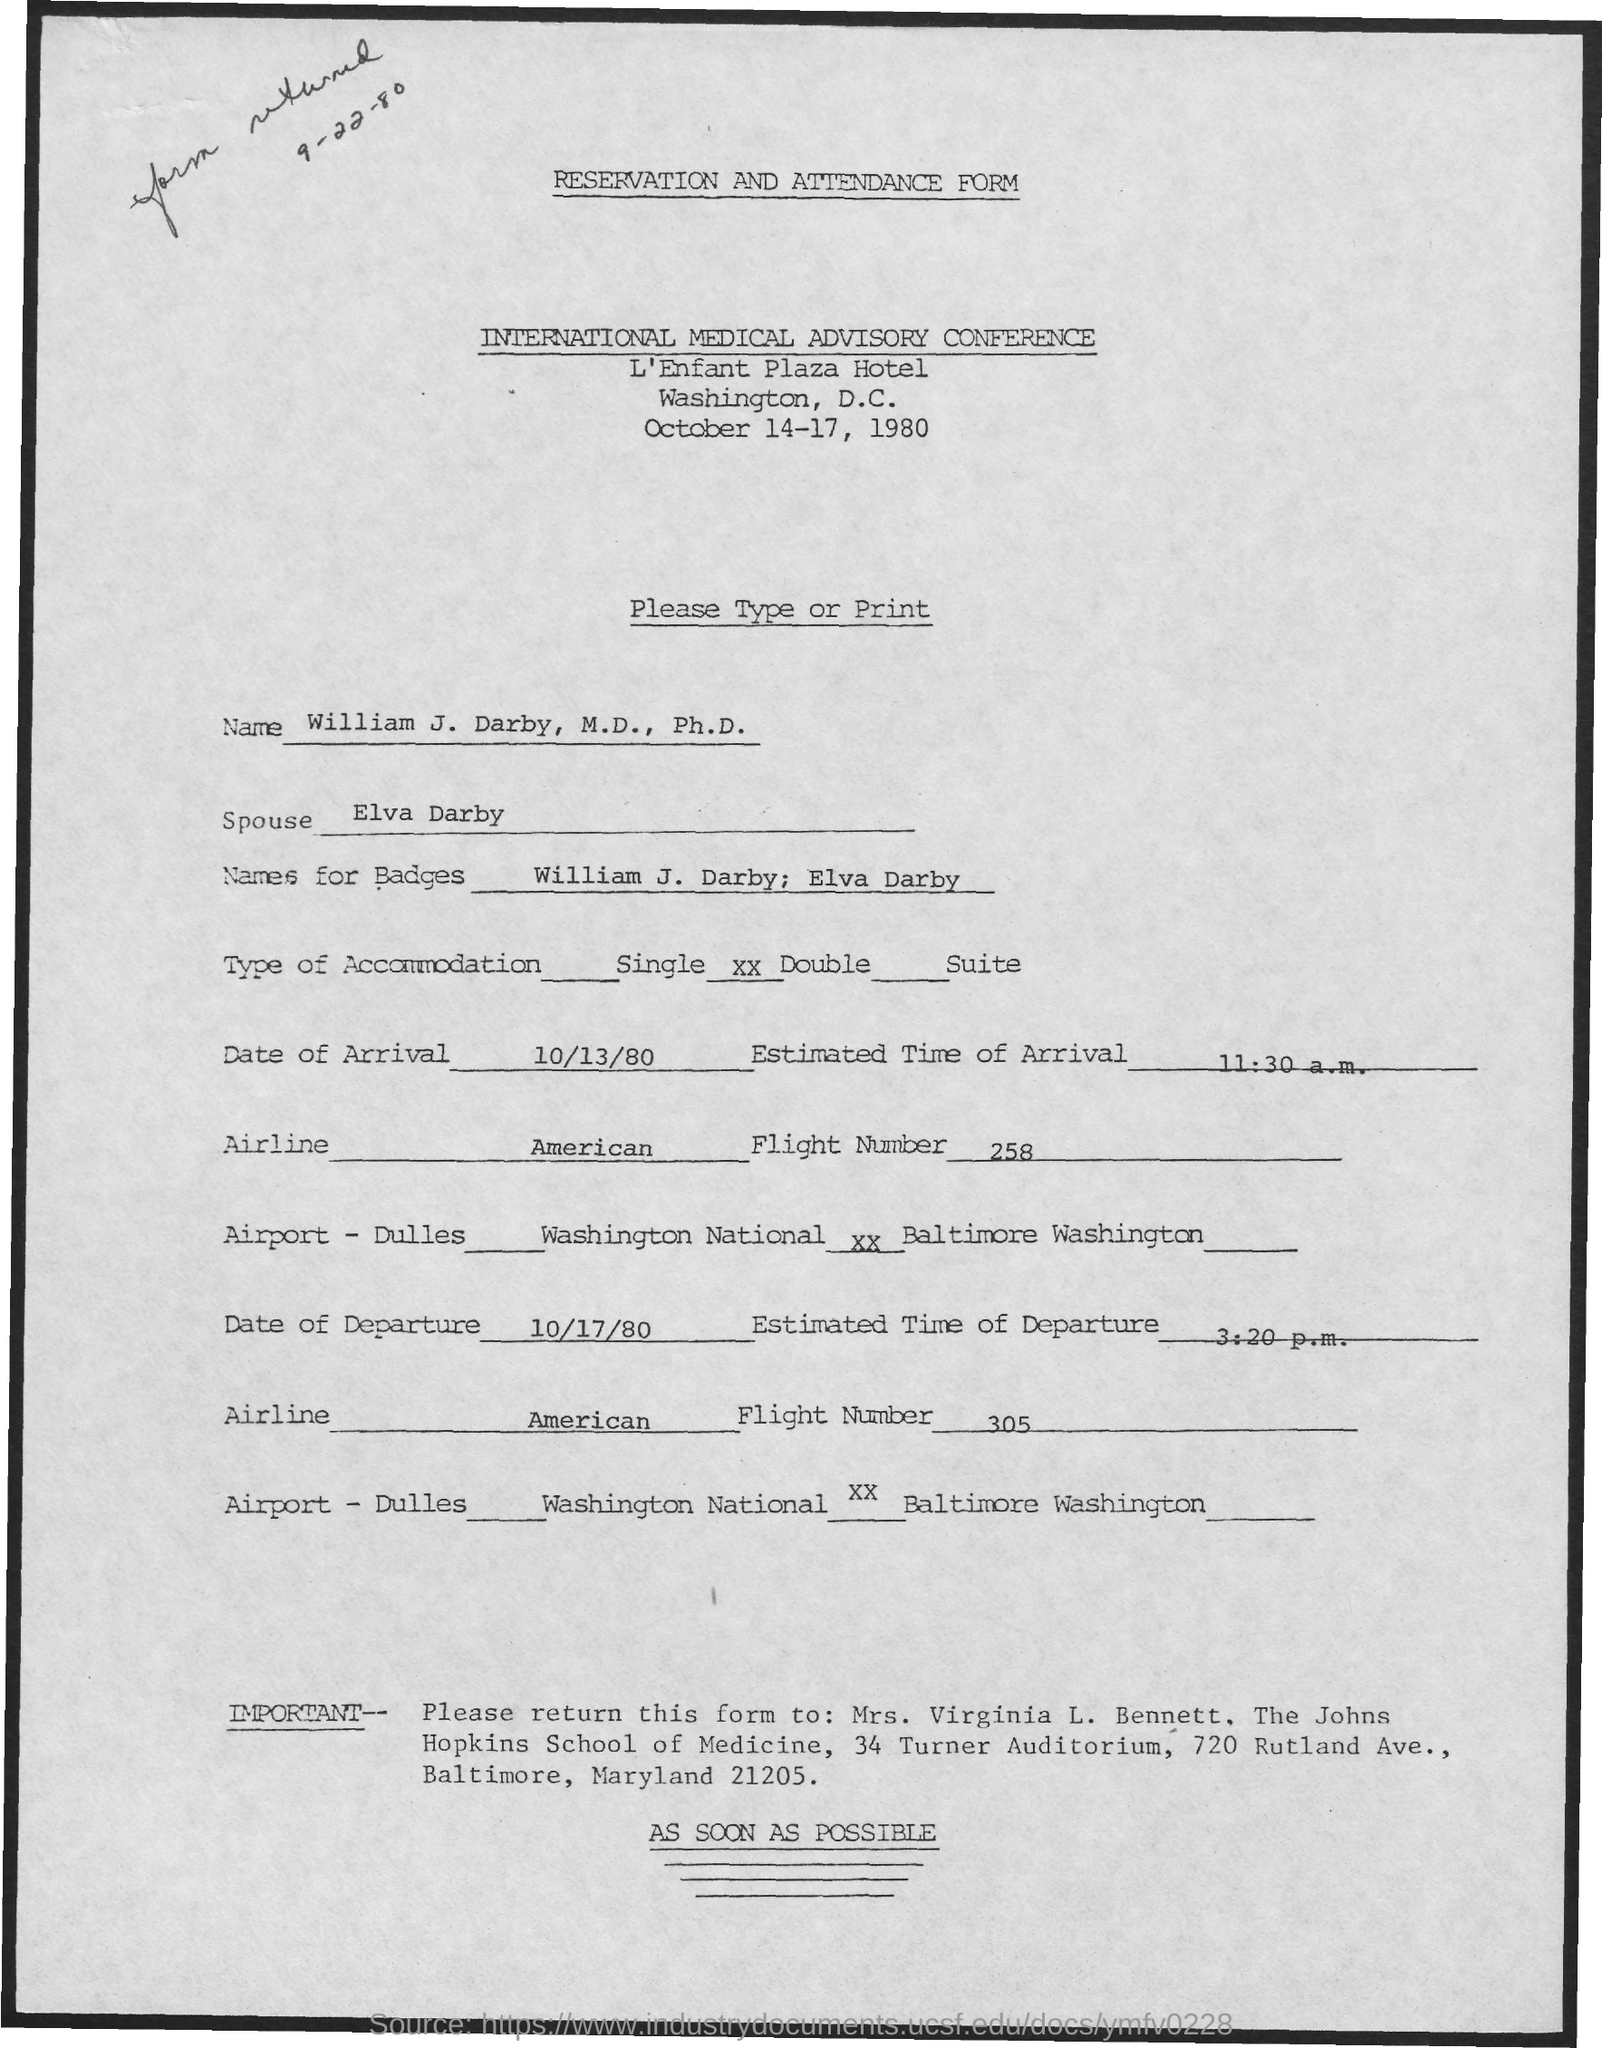What form is this?
Your answer should be compact. RESERVATION AND ATTENDANCE FORM. What is the name of the conference?
Keep it short and to the point. INTERNATIONAL MEDICAL ADVISORY CONFERENCE. When is the conference going to be held?
Your response must be concise. October 14-17, 1980. What is the name given?
Make the answer very short. William J. Darby. Who is William's spouse?
Your answer should be compact. Elva Darby. What is the type of accommodation?
Your answer should be compact. Double. When is the arrival?
Offer a very short reply. 10/13/80. What is the number of the departing flight?
Offer a very short reply. 305. 